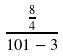Convert formula to latex. <formula><loc_0><loc_0><loc_500><loc_500>\frac { \frac { 8 } { 4 } } { 1 0 1 - 3 }</formula> 